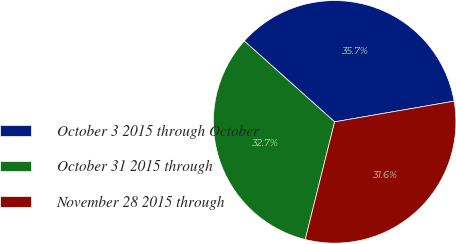Convert chart. <chart><loc_0><loc_0><loc_500><loc_500><pie_chart><fcel>October 3 2015 through October<fcel>October 31 2015 through<fcel>November 28 2015 through<nl><fcel>35.65%<fcel>32.72%<fcel>31.63%<nl></chart> 